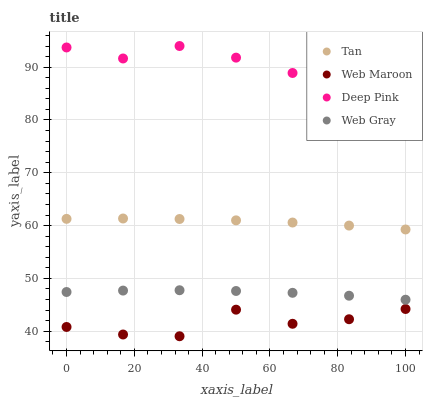Does Web Maroon have the minimum area under the curve?
Answer yes or no. Yes. Does Deep Pink have the maximum area under the curve?
Answer yes or no. Yes. Does Tan have the minimum area under the curve?
Answer yes or no. No. Does Tan have the maximum area under the curve?
Answer yes or no. No. Is Tan the smoothest?
Answer yes or no. Yes. Is Deep Pink the roughest?
Answer yes or no. Yes. Is Deep Pink the smoothest?
Answer yes or no. No. Is Tan the roughest?
Answer yes or no. No. Does Web Maroon have the lowest value?
Answer yes or no. Yes. Does Tan have the lowest value?
Answer yes or no. No. Does Deep Pink have the highest value?
Answer yes or no. Yes. Does Tan have the highest value?
Answer yes or no. No. Is Web Maroon less than Deep Pink?
Answer yes or no. Yes. Is Deep Pink greater than Tan?
Answer yes or no. Yes. Does Web Maroon intersect Deep Pink?
Answer yes or no. No. 